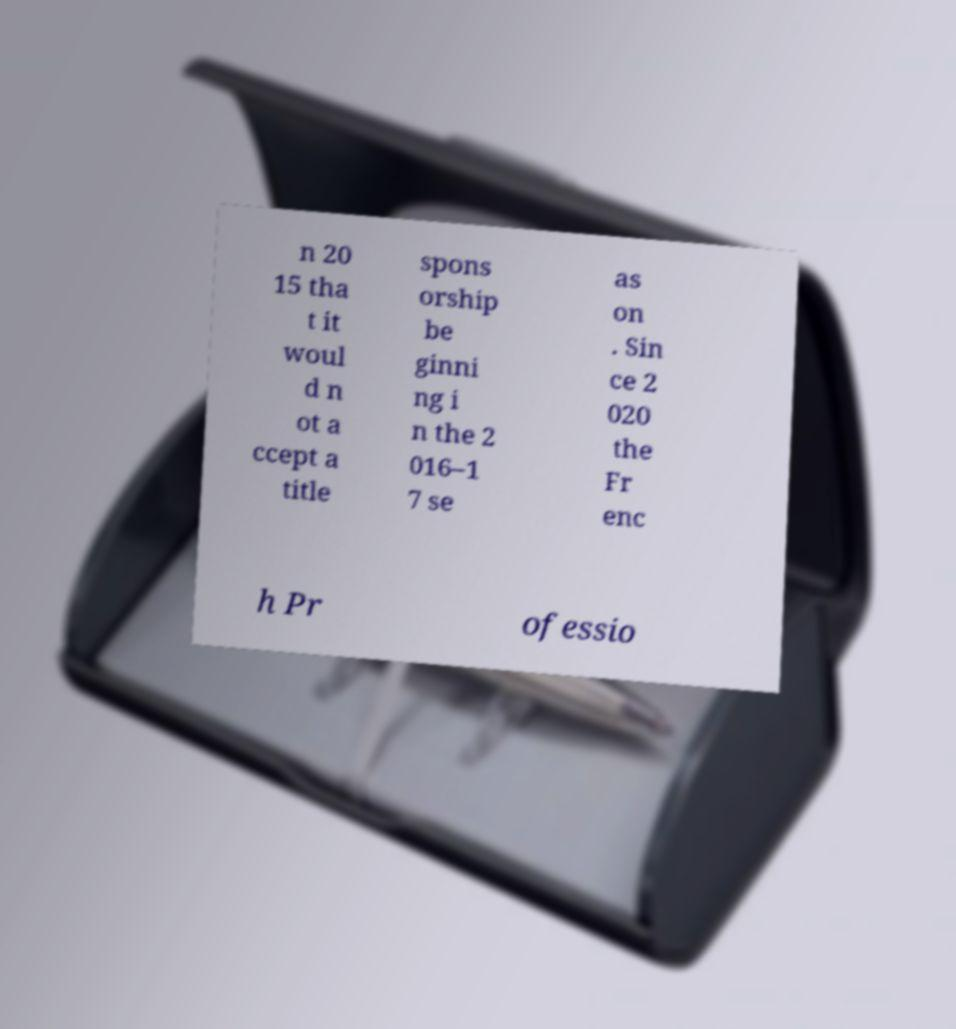For documentation purposes, I need the text within this image transcribed. Could you provide that? n 20 15 tha t it woul d n ot a ccept a title spons orship be ginni ng i n the 2 016–1 7 se as on . Sin ce 2 020 the Fr enc h Pr ofessio 